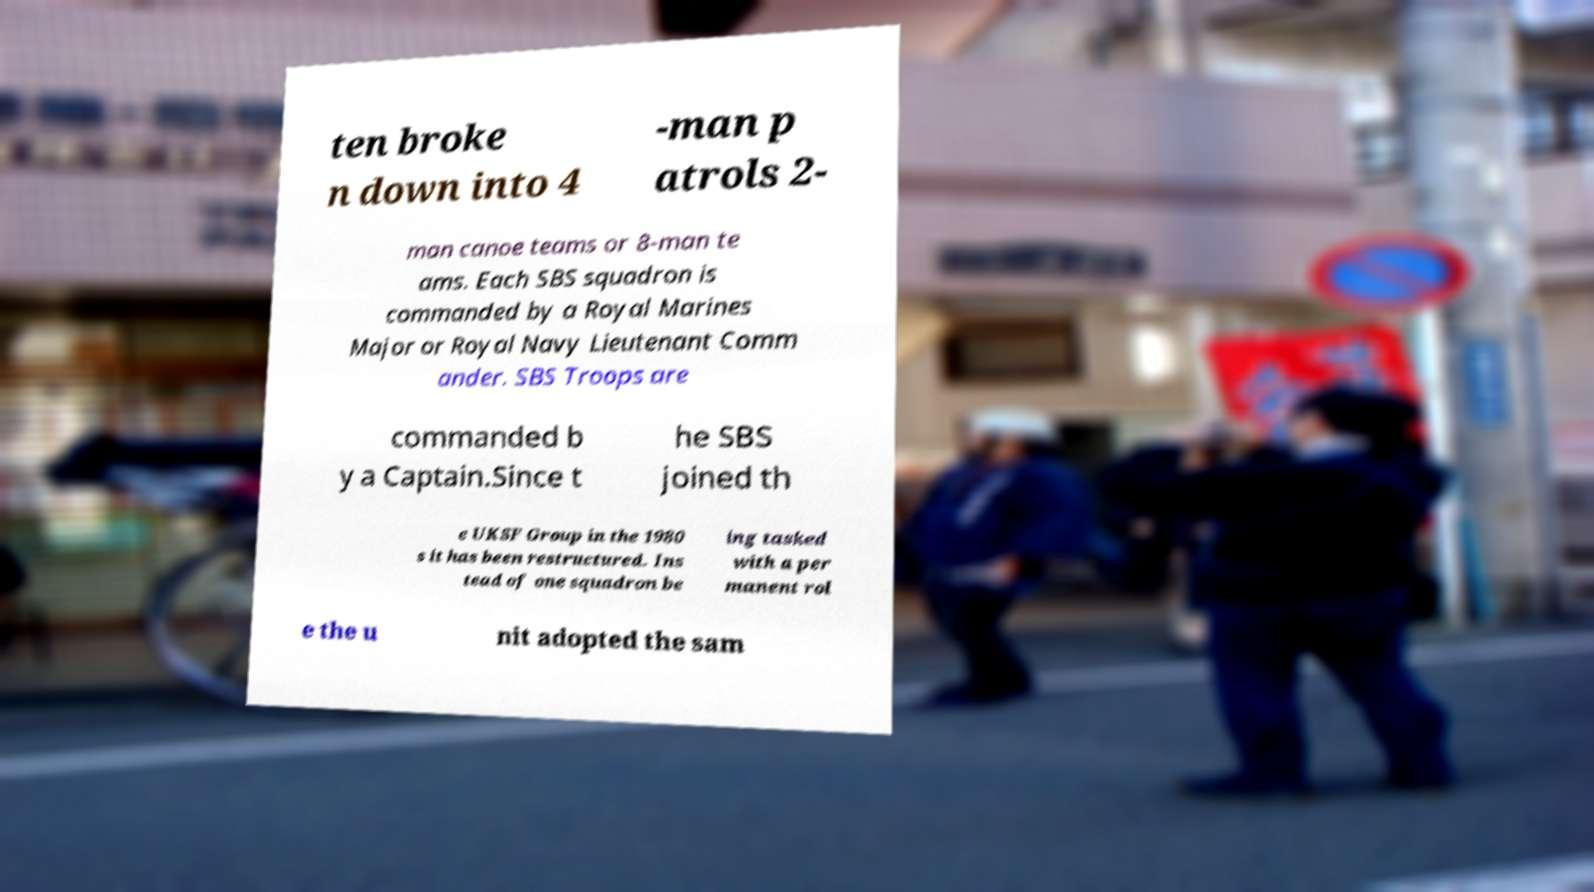Could you assist in decoding the text presented in this image and type it out clearly? ten broke n down into 4 -man p atrols 2- man canoe teams or 8-man te ams. Each SBS squadron is commanded by a Royal Marines Major or Royal Navy Lieutenant Comm ander. SBS Troops are commanded b y a Captain.Since t he SBS joined th e UKSF Group in the 1980 s it has been restructured. Ins tead of one squadron be ing tasked with a per manent rol e the u nit adopted the sam 